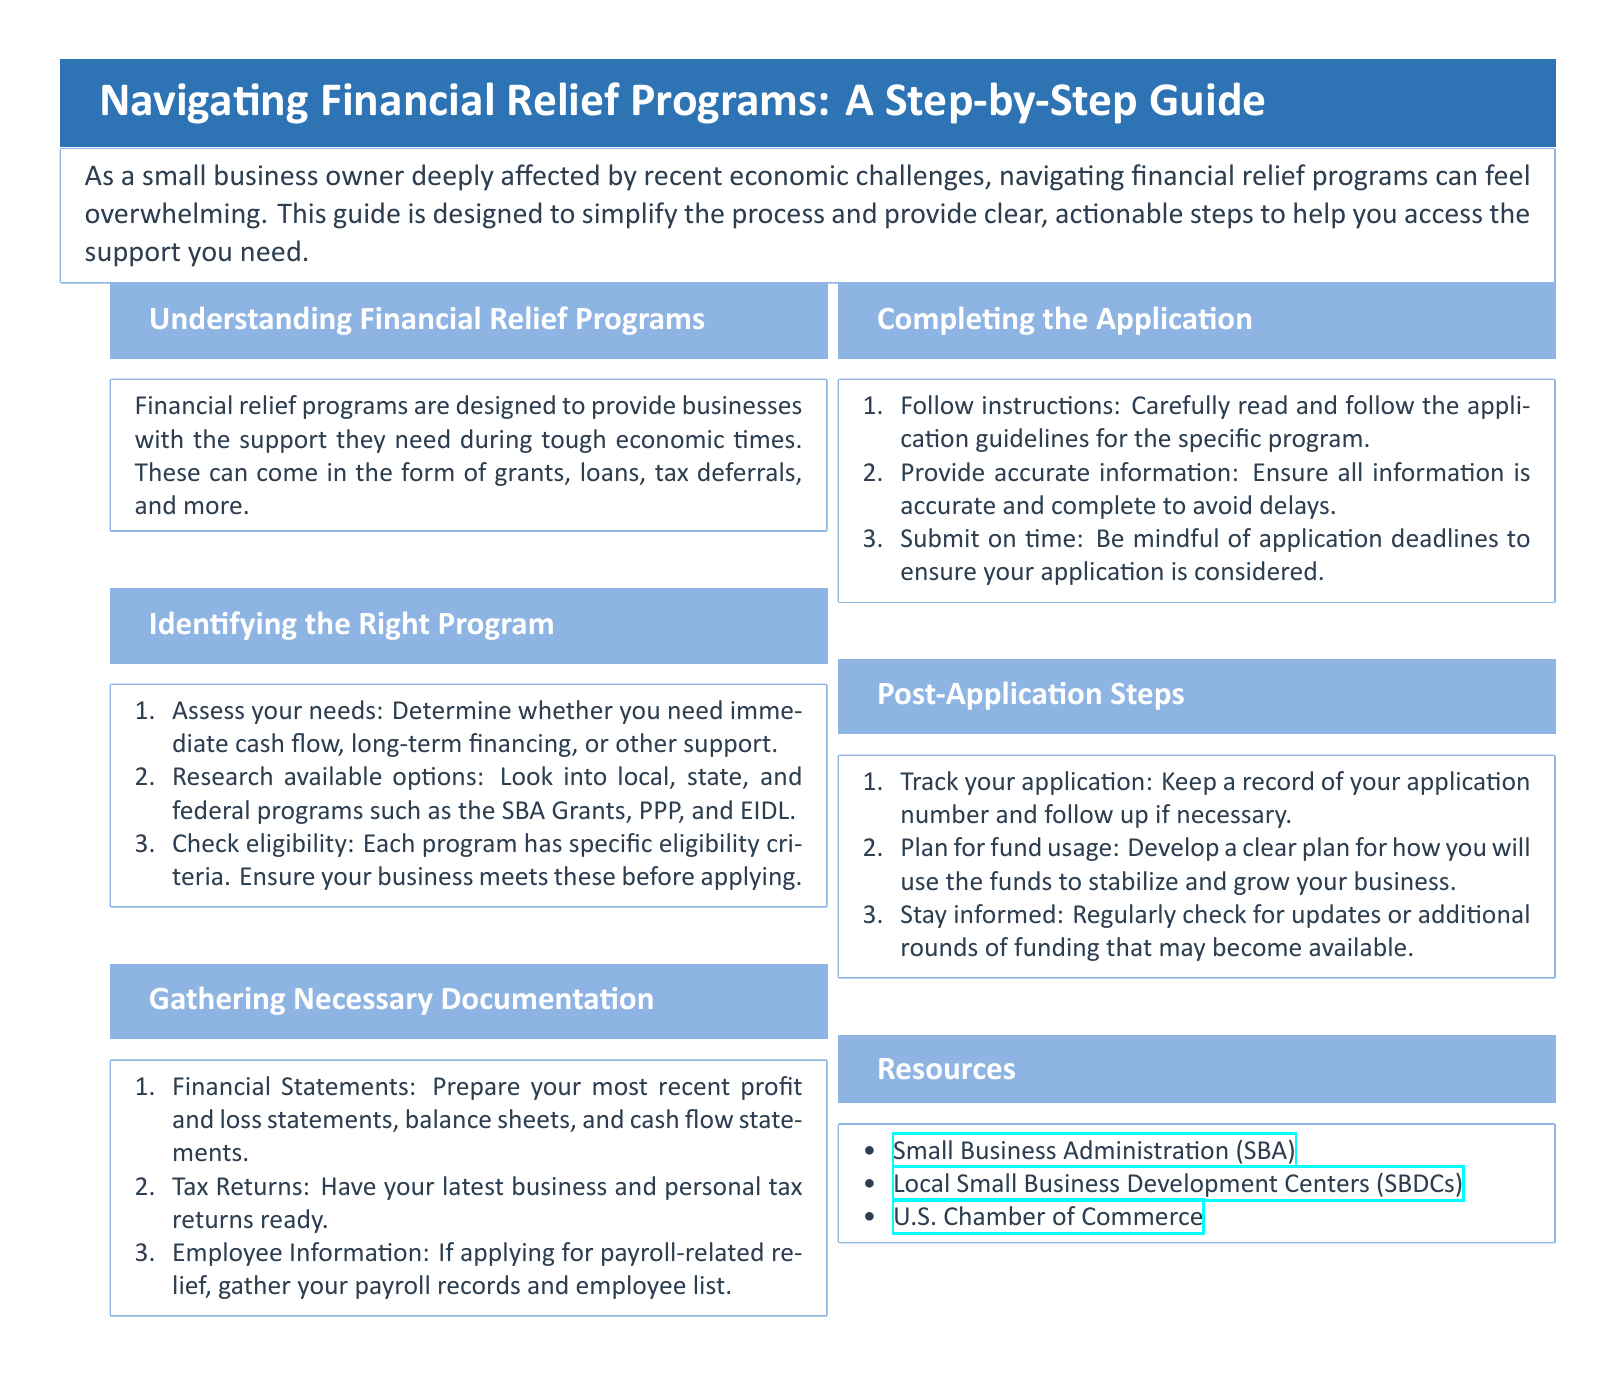What are financial relief programs designed for? Financial relief programs are designed to provide businesses with the support they need during tough economic times.
Answer: Support for businesses What types of available options should I research? The document suggests looking into local, state, and federal programs like the SBA Grants, PPP, and EIDL.
Answer: SBA Grants, PPP, EIDL What are some examples of necessary documentation to gather? Examples include financial statements, tax returns, and employee information.
Answer: Financial statements, tax returns, employee information What is the first step in completing the application? The first step is to carefully read and follow the application guidelines for the specific program.
Answer: Read application guidelines What should you do after submitting the application? After submitting, you should track your application and stay informed about updates.
Answer: Track application, stay informed What should you plan for after receiving the funds? You should develop a clear plan for how you will use the funds to stabilize and grow your business.
Answer: Plan for fund usage Which organization offers local small business assistance? The Small Business Development Centers (SBDCs) provide local assistance.
Answer: Small Business Development Centers How can you check eligibility for a financial relief program? You need to ensure your business meets the specific eligibility criteria listed for each program.
Answer: Check specific eligibility criteria What is the primary document type of this material? This material is a user guide aimed at helping small business owners navigate financial relief programs.
Answer: User guide 